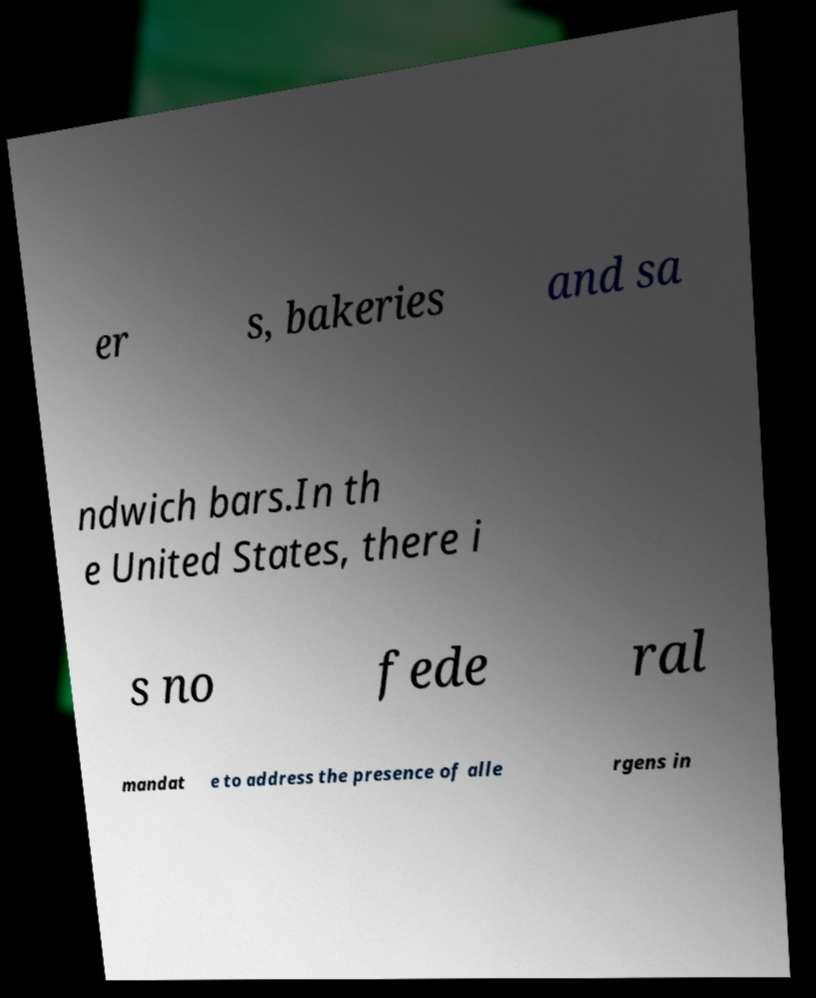Please identify and transcribe the text found in this image. er s, bakeries and sa ndwich bars.In th e United States, there i s no fede ral mandat e to address the presence of alle rgens in 